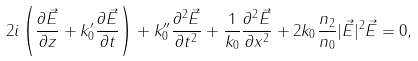<formula> <loc_0><loc_0><loc_500><loc_500>2 i \left ( \frac { \partial \vec { E } } { \partial z } + k ^ { \prime } _ { 0 } \frac { \partial \vec { E } } { \partial t } \right ) + k ^ { \prime \prime } _ { 0 } \frac { \partial ^ { 2 } \vec { E } } { \partial t ^ { 2 } } + \frac { 1 } { k _ { 0 } } \frac { \partial ^ { 2 } \vec { E } } { \partial x ^ { 2 } } + 2 k _ { 0 } \frac { n _ { 2 } } { n _ { 0 } } | \vec { E } | ^ { 2 } \vec { E } = 0 ,</formula> 